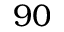Convert formula to latex. <formula><loc_0><loc_0><loc_500><loc_500>9 0</formula> 